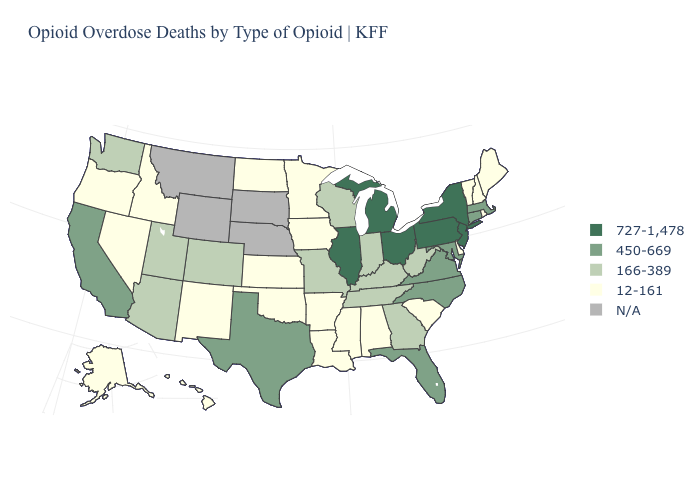What is the value of Delaware?
Write a very short answer. 12-161. What is the value of New Hampshire?
Write a very short answer. 12-161. Name the states that have a value in the range 727-1,478?
Keep it brief. Illinois, Michigan, New Jersey, New York, Ohio, Pennsylvania. Does South Carolina have the lowest value in the South?
Answer briefly. Yes. Name the states that have a value in the range 727-1,478?
Short answer required. Illinois, Michigan, New Jersey, New York, Ohio, Pennsylvania. Name the states that have a value in the range N/A?
Short answer required. Montana, Nebraska, South Dakota, Wyoming. Name the states that have a value in the range 12-161?
Quick response, please. Alabama, Alaska, Arkansas, Delaware, Hawaii, Idaho, Iowa, Kansas, Louisiana, Maine, Minnesota, Mississippi, Nevada, New Hampshire, New Mexico, North Dakota, Oklahoma, Oregon, Rhode Island, South Carolina, Vermont. Name the states that have a value in the range N/A?
Answer briefly. Montana, Nebraska, South Dakota, Wyoming. Name the states that have a value in the range 12-161?
Answer briefly. Alabama, Alaska, Arkansas, Delaware, Hawaii, Idaho, Iowa, Kansas, Louisiana, Maine, Minnesota, Mississippi, Nevada, New Hampshire, New Mexico, North Dakota, Oklahoma, Oregon, Rhode Island, South Carolina, Vermont. What is the value of North Dakota?
Quick response, please. 12-161. Name the states that have a value in the range N/A?
Give a very brief answer. Montana, Nebraska, South Dakota, Wyoming. What is the highest value in the South ?
Write a very short answer. 450-669. Among the states that border Maryland , does West Virginia have the lowest value?
Quick response, please. No. Which states hav the highest value in the South?
Be succinct. Florida, Maryland, North Carolina, Texas, Virginia. 